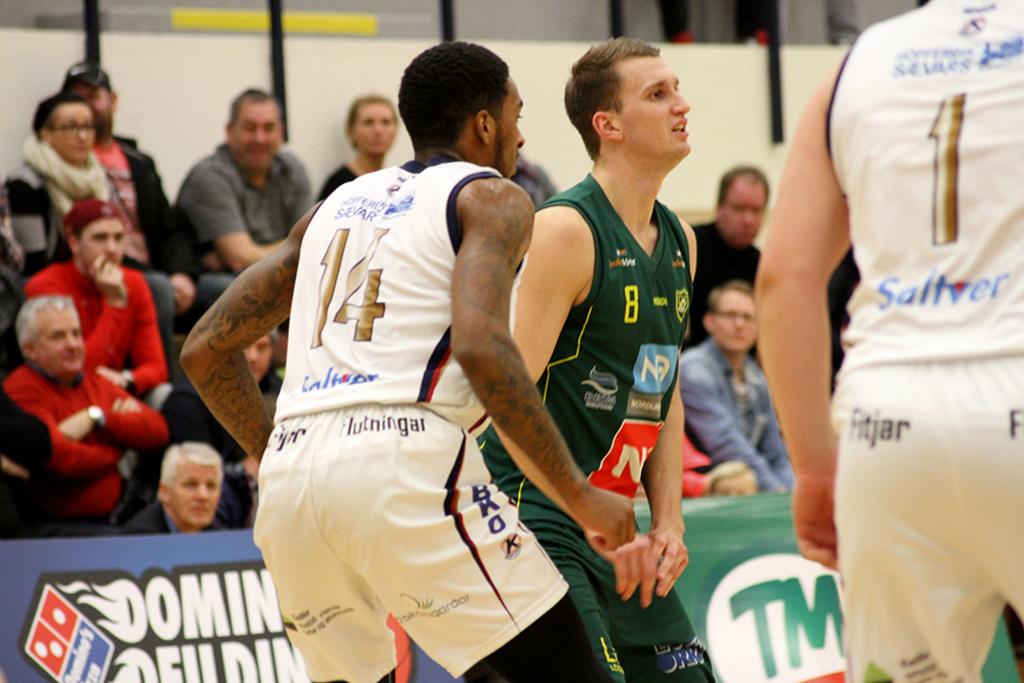What number in on the back of the player on the far right?
Provide a short and direct response. 1. 